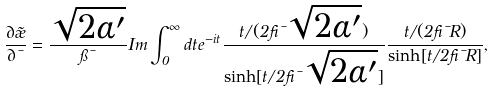Convert formula to latex. <formula><loc_0><loc_0><loc_500><loc_500>\frac { \partial \tilde { \rho } } { \partial \mu } = \frac { \sqrt { 2 \alpha ^ { \prime } } } { \pi \mu } I m \int _ { 0 } ^ { \infty } d t e ^ { - i t } \frac { t / ( 2 \beta \mu \sqrt { 2 \alpha ^ { \prime } } ) } { \sinh [ t / 2 \beta \mu \sqrt { 2 \alpha ^ { \prime } } ] } \frac { t / ( 2 \beta \mu R ) } { \sinh [ t / 2 \beta \mu R ] } ,</formula> 